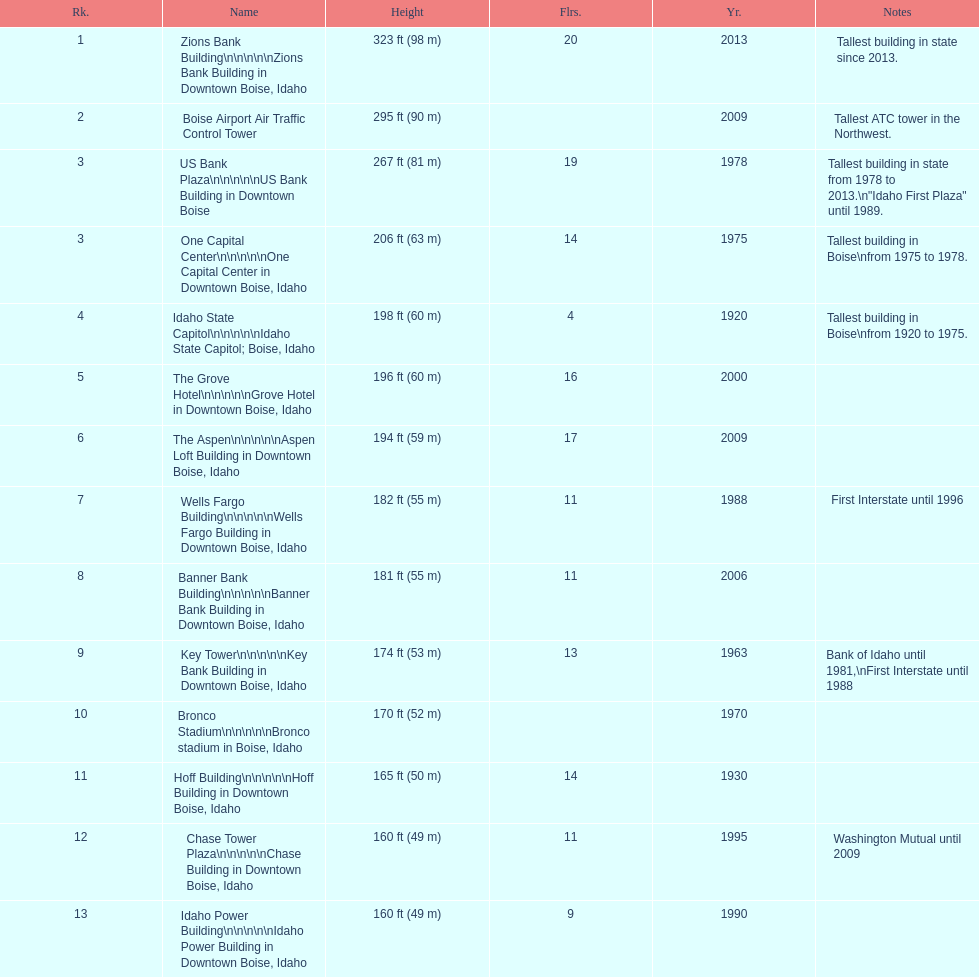What are the number of floors the us bank plaza has? 19. 